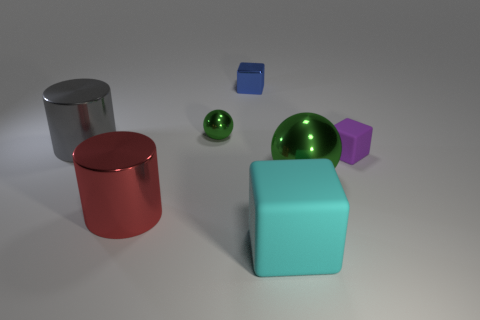What is the size of the other sphere that is the same color as the large shiny sphere?
Ensure brevity in your answer.  Small. Do the metallic ball in front of the large gray cylinder and the tiny shiny sphere have the same color?
Keep it short and to the point. Yes. Does the small metal sphere have the same color as the big ball?
Provide a succinct answer. Yes. There is a matte cube that is in front of the big red shiny object; how many big rubber blocks are to the right of it?
Offer a very short reply. 0. What is the size of the metallic object that is in front of the small sphere and behind the large green shiny sphere?
Your answer should be very brief. Large. Do the large cube and the tiny cube that is behind the purple matte cube have the same material?
Make the answer very short. No. Are there fewer large red metallic cylinders in front of the small blue metal cube than green metallic things that are behind the red cylinder?
Keep it short and to the point. Yes. There is a object behind the small green sphere; what is it made of?
Your answer should be very brief. Metal. What is the color of the metal object that is both behind the big gray thing and left of the tiny blue block?
Your answer should be compact. Green. How many other things are there of the same color as the small ball?
Your response must be concise. 1. 